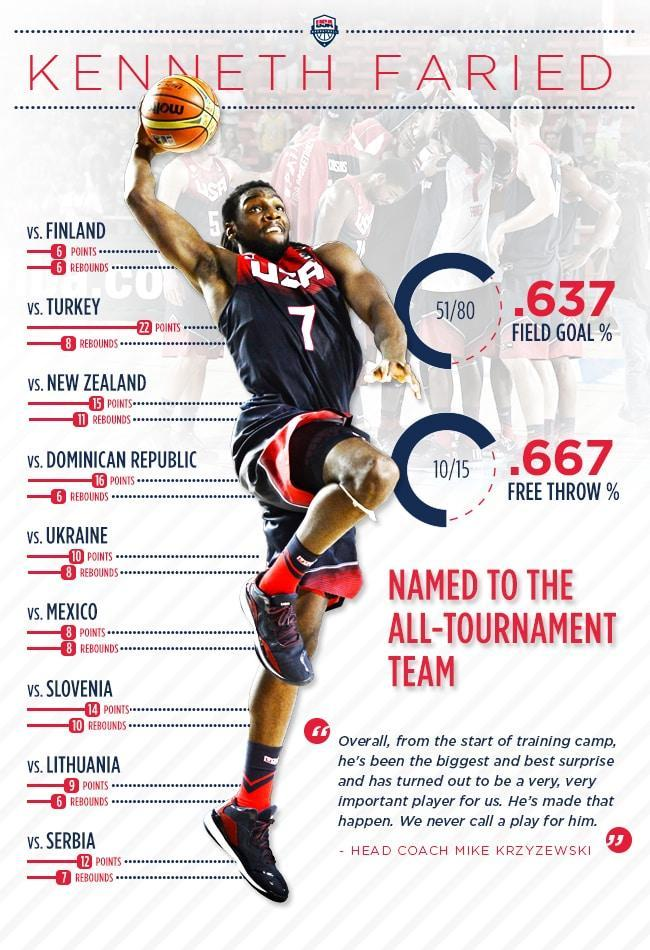Against which country did Faried score the highest number of rebounds?
Answer the question with a short phrase. Slovenia In how many matches did Faried score 8 rebounds? 3 What was the points scored by Kenneth in the match against Turkey? 22 points Which club does Kenneth Faried play for ? USA What was the jersey number of Kenneth Faried? 7 What was the total points scored by Faried in the match against Serbia and Ukraine? 22 What is lowest number of rebounds scored by Faried? 6 How many countries has club USA played played with ? 9 What was the highest points scored by Faried ? 22 points 